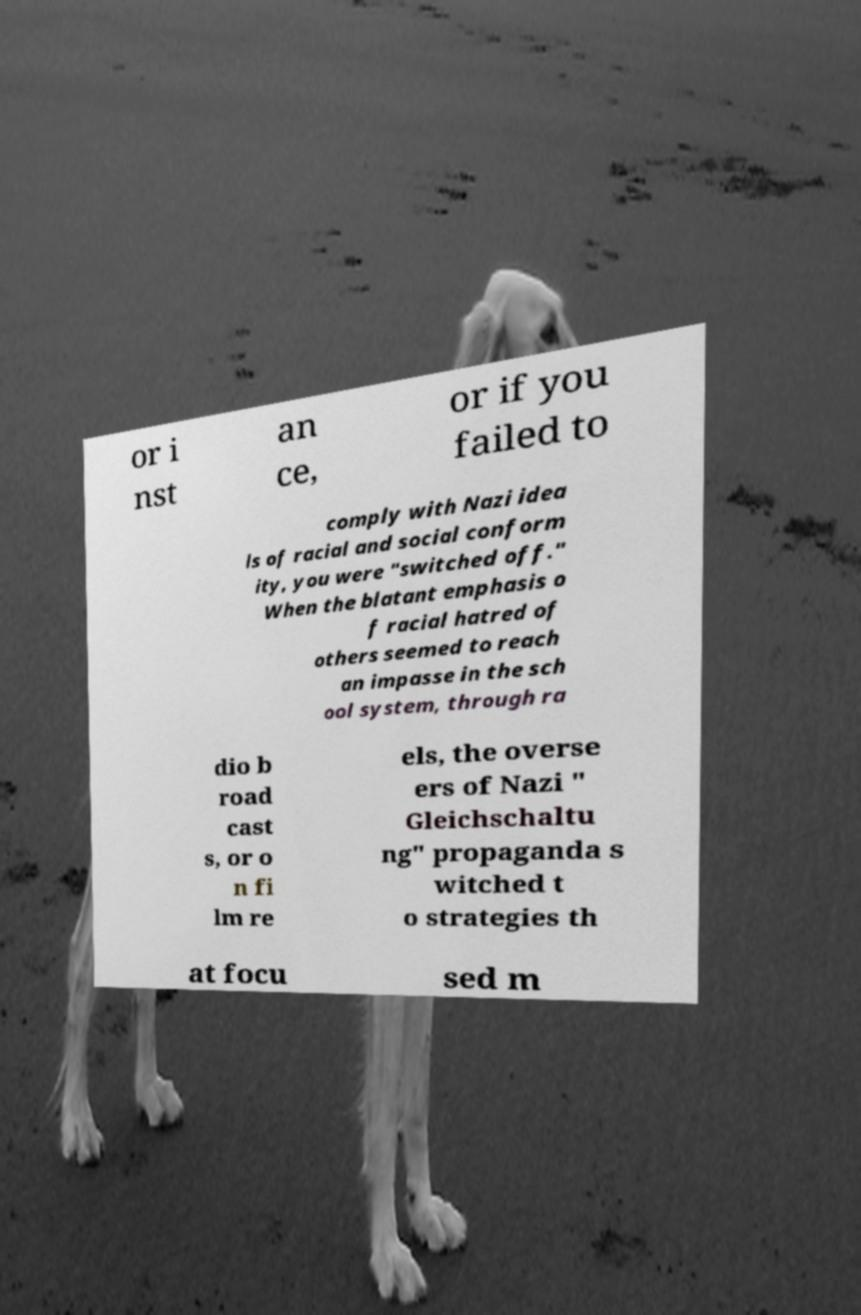Please read and relay the text visible in this image. What does it say? or i nst an ce, or if you failed to comply with Nazi idea ls of racial and social conform ity, you were "switched off." When the blatant emphasis o f racial hatred of others seemed to reach an impasse in the sch ool system, through ra dio b road cast s, or o n fi lm re els, the overse ers of Nazi " Gleichschaltu ng" propaganda s witched t o strategies th at focu sed m 